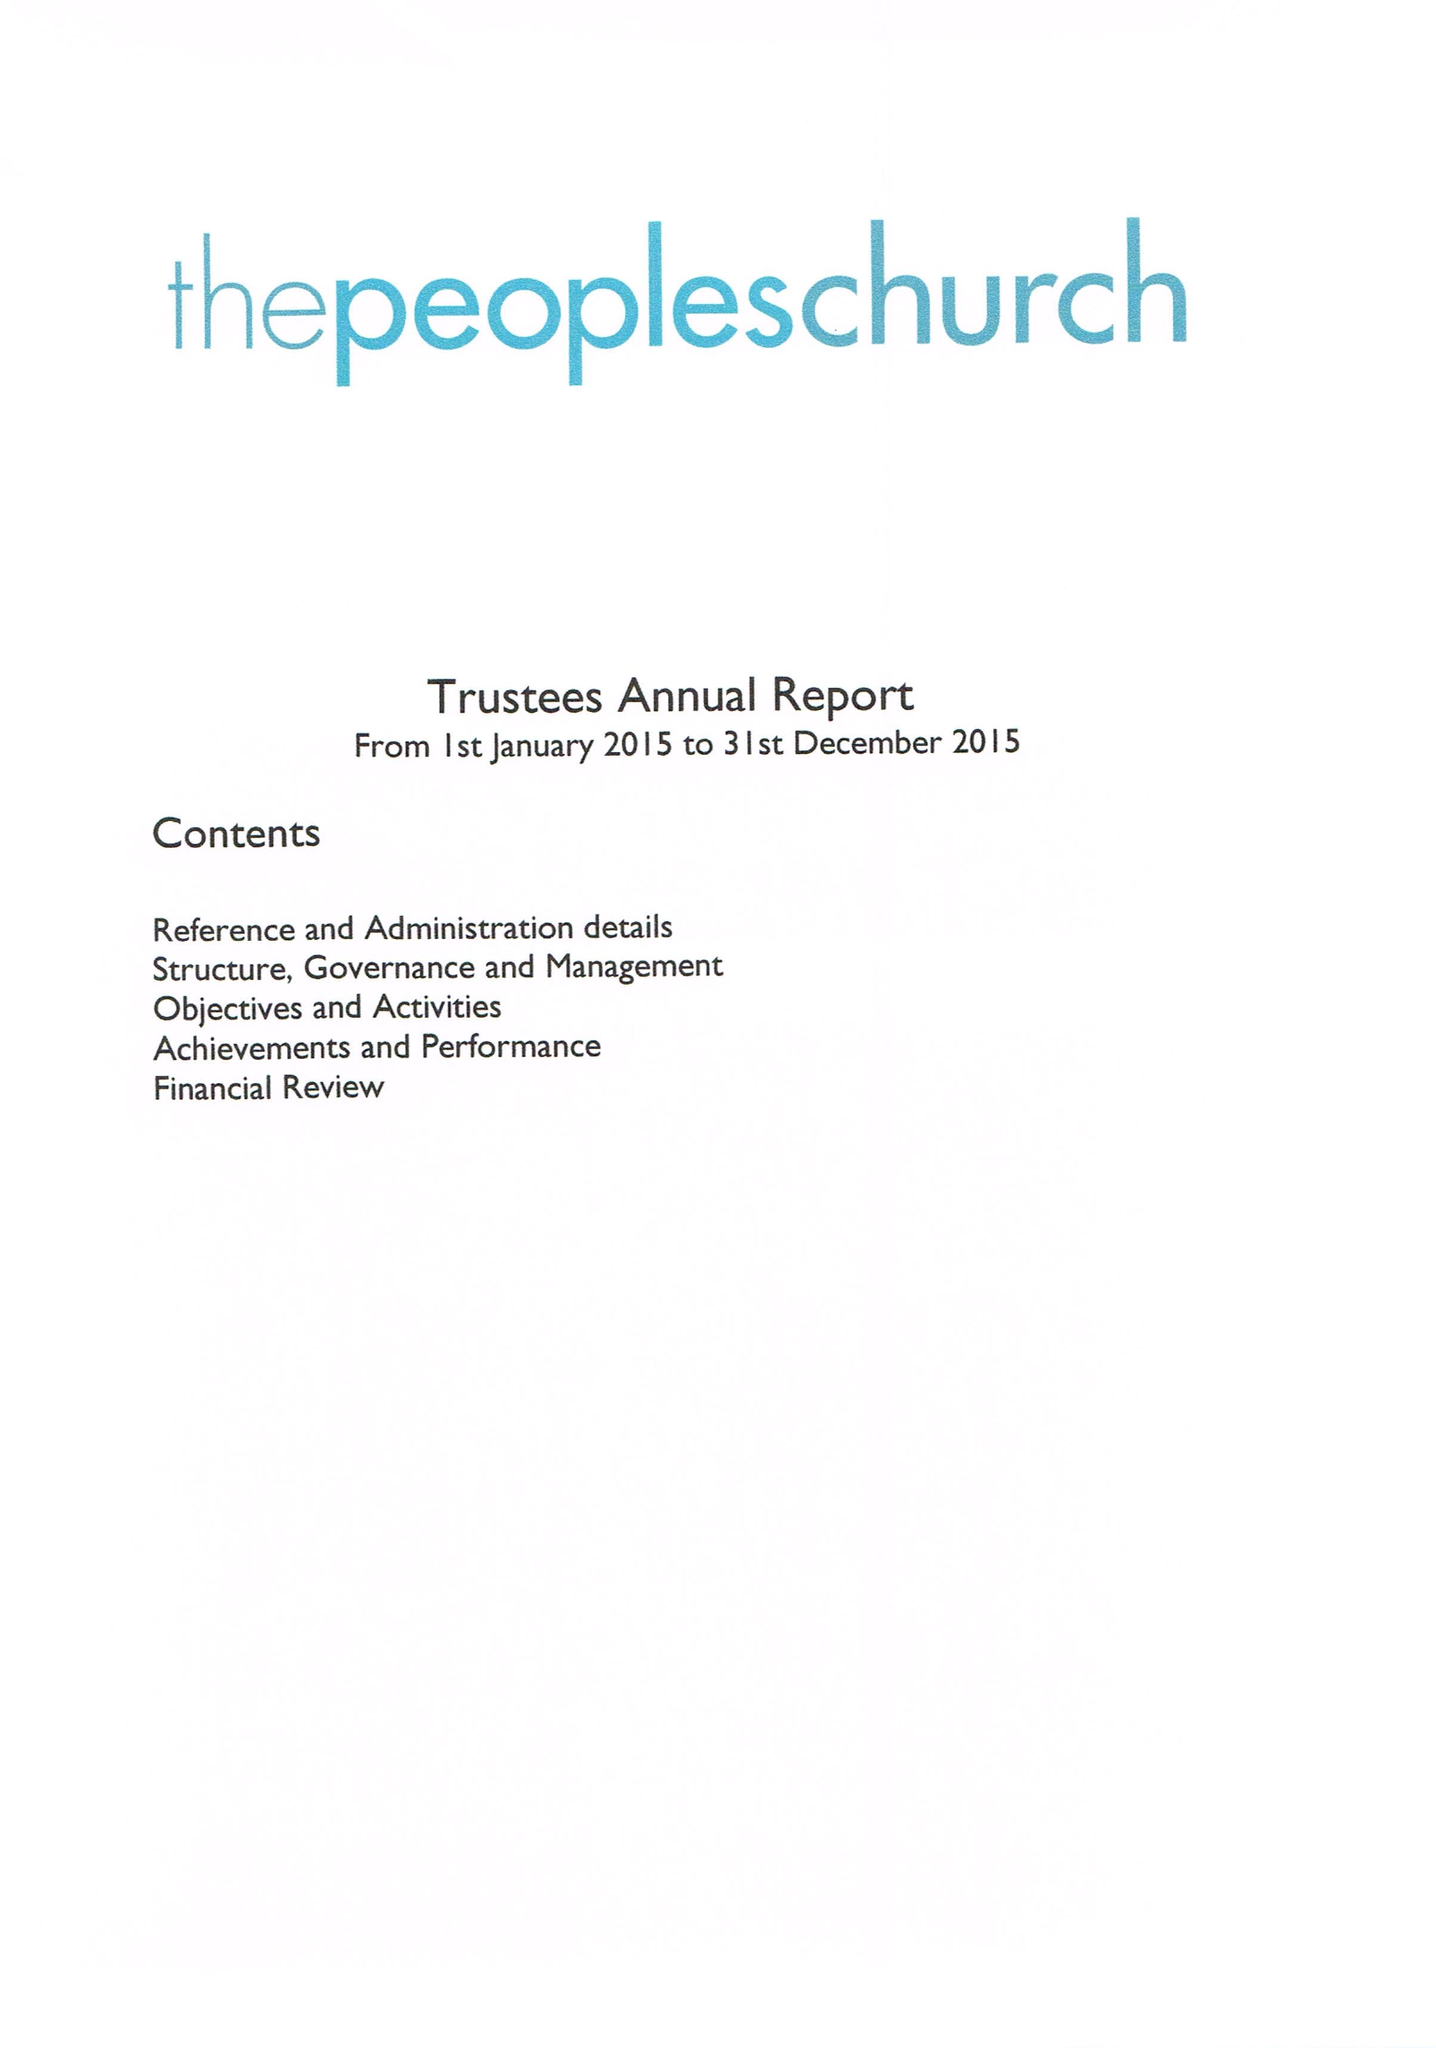What is the value for the income_annually_in_british_pounds?
Answer the question using a single word or phrase. 186430.00 